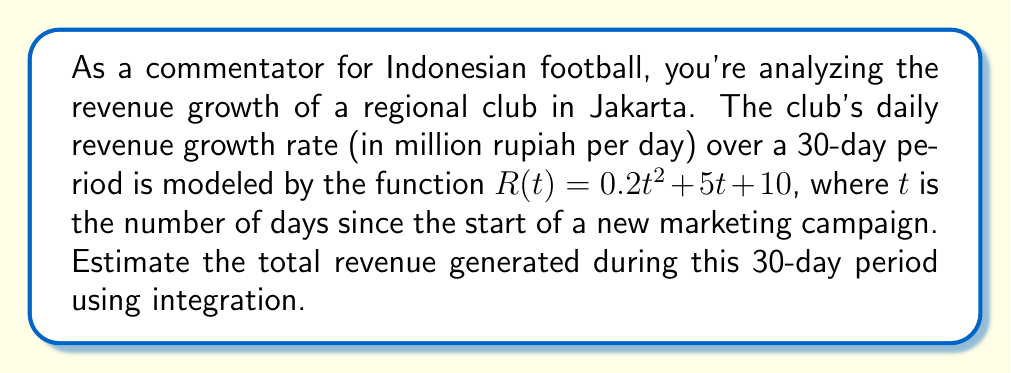Solve this math problem. To estimate the total revenue generated during the 30-day period, we need to calculate the definite integral of the revenue growth rate function from day 0 to day 30.

1) The revenue growth rate function is given as:
   $R(t) = 0.2t^2 + 5t + 10$

2) We need to integrate this function from $t=0$ to $t=30$:
   $\int_0^{30} (0.2t^2 + 5t + 10) dt$

3) Let's integrate each term:
   $\int_0^{30} 0.2t^2 dt + \int_0^{30} 5t dt + \int_0^{30} 10 dt$

4) Applying the power rule of integration:
   $[\frac{0.2t^3}{3}]_0^{30} + [\frac{5t^2}{2}]_0^{30} + [10t]_0^{30}$

5) Evaluating at the limits:
   $(\frac{0.2(30^3)}{3} - 0) + (\frac{5(30^2)}{2} - 0) + (10(30) - 0)$

6) Simplifying:
   $\frac{0.2(27000)}{3} + \frac{5(900)}{2} + 300$
   $= 1800 + 2250 + 300$
   $= 4350$

Therefore, the estimated total revenue generated during the 30-day period is 4350 million rupiah.
Answer: 4350 million rupiah 